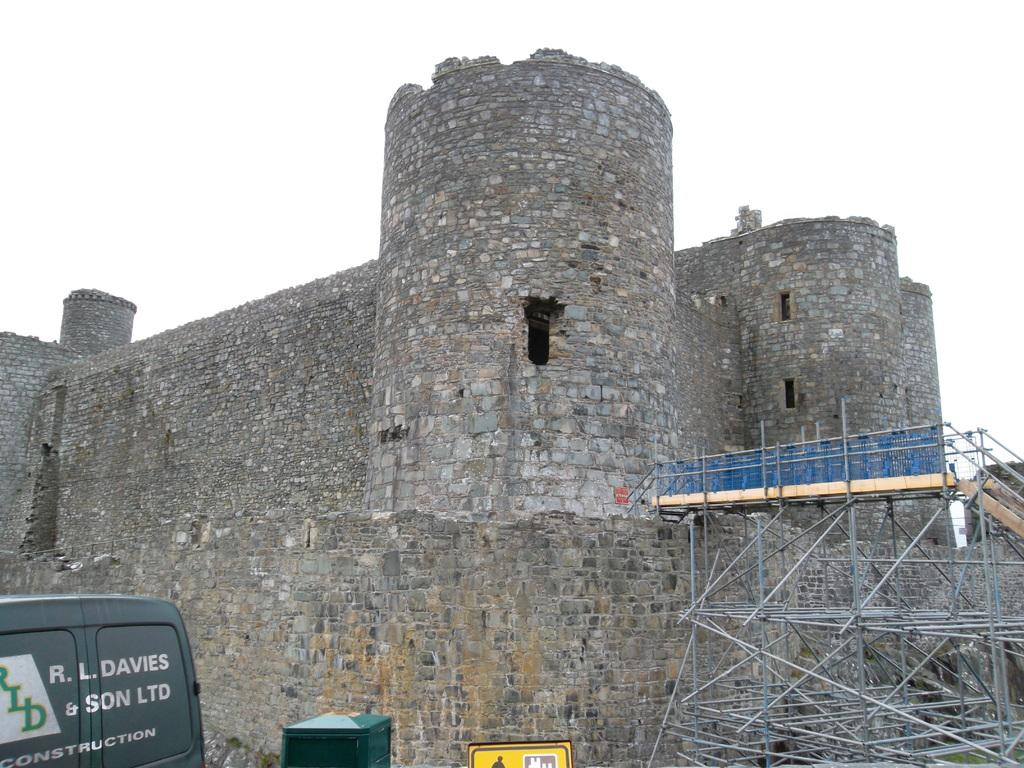What type of structure is in the picture? There is a fort in the picture. What can be seen on the right side of the picture? There are metal objects on the right side of the picture. What is located on the left side of the picture? There is a vehicle on the left side of the picture. What is the interest rate for the fictional loan mentioned in the picture? There is no mention of a loan or interest rate in the picture; it features a fort, metal objects, and a vehicle. 